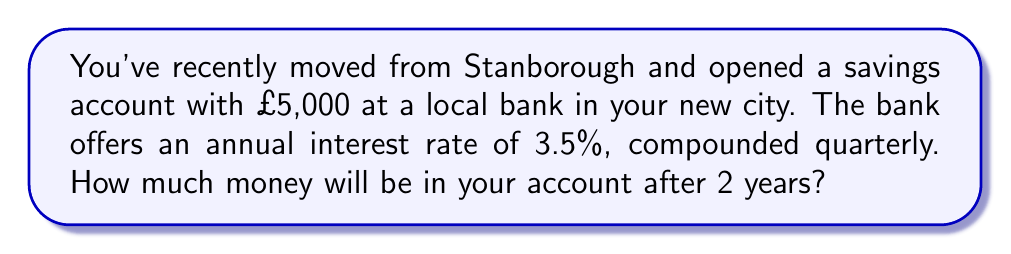Help me with this question. Let's approach this step-by-step using the compound interest formula:

$$A = P(1 + \frac{r}{n})^{nt}$$

Where:
$A$ = Final amount
$P$ = Principal (initial investment)
$r$ = Annual interest rate (in decimal form)
$n$ = Number of times interest is compounded per year
$t$ = Number of years

Given:
$P = £5,000$
$r = 3.5\% = 0.035$
$n = 4$ (quarterly compounding)
$t = 2$ years

Let's substitute these values into the formula:

$$A = 5000(1 + \frac{0.035}{4})^{4(2)}$$

$$A = 5000(1 + 0.00875)^8$$

$$A = 5000(1.00875)^8$$

Using a calculator or computer:

$$A = 5000 \times 1.0719784$$

$$A = 5359.89$$

Therefore, after 2 years, your account will contain £5,359.89 (rounded to the nearest penny).
Answer: £5,359.89 